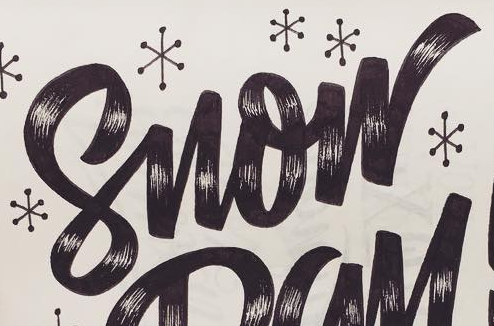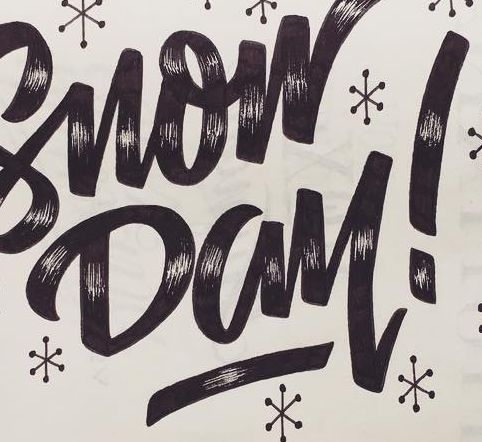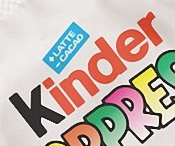What text is displayed in these images sequentially, separated by a semicolon? Snow; Day!; Kinder 